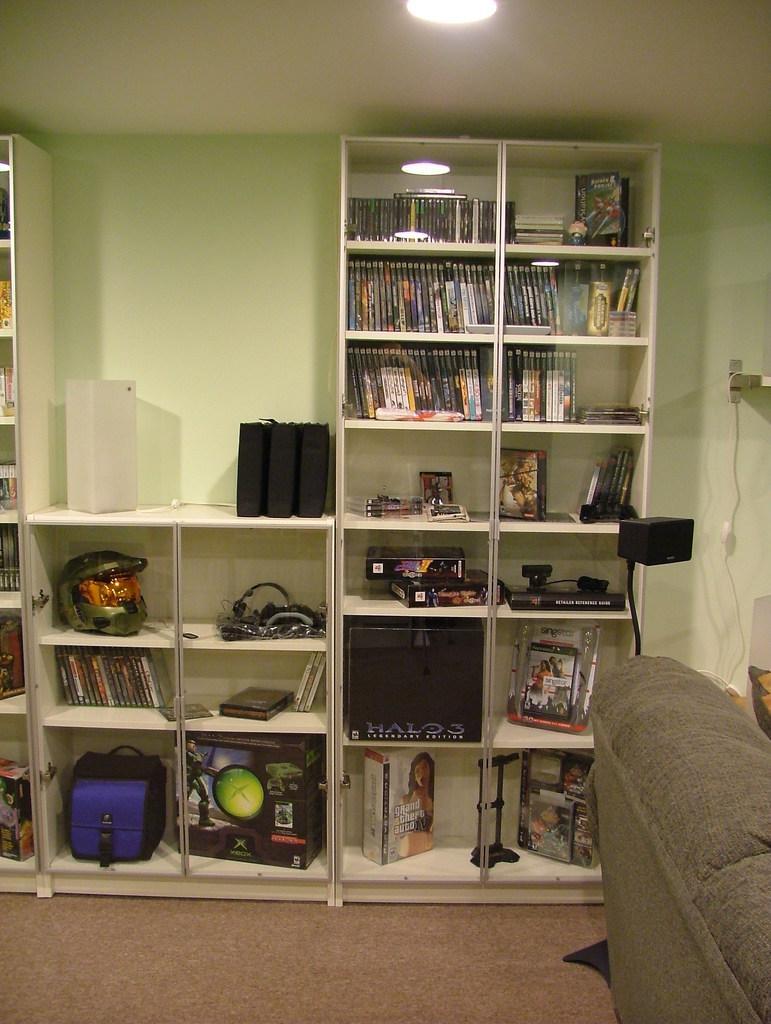Can you describe this image briefly? This is an inside view of a room. On the right side there is a couch. In the background, I can see the racks in which books, bag, boxes, helmet, wires, photo frame and some other objects are placed. At the back of it I can see the wall. At the top there is a light to the roof. 